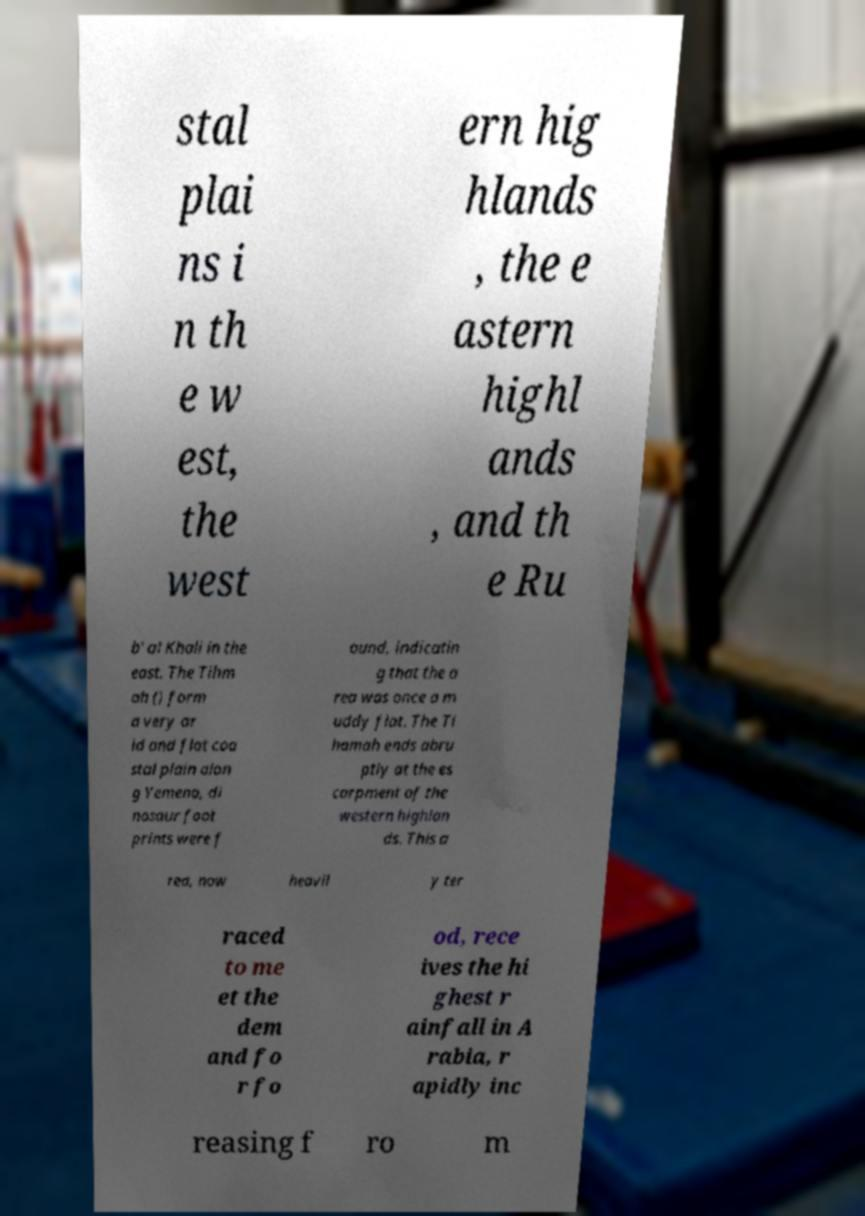What messages or text are displayed in this image? I need them in a readable, typed format. stal plai ns i n th e w est, the west ern hig hlands , the e astern highl ands , and th e Ru b' al Khali in the east. The Tihm ah () form a very ar id and flat coa stal plain alon g Yemena, di nosaur foot prints were f ound, indicatin g that the a rea was once a m uddy flat. The Ti hamah ends abru ptly at the es carpment of the western highlan ds. This a rea, now heavil y ter raced to me et the dem and fo r fo od, rece ives the hi ghest r ainfall in A rabia, r apidly inc reasing f ro m 